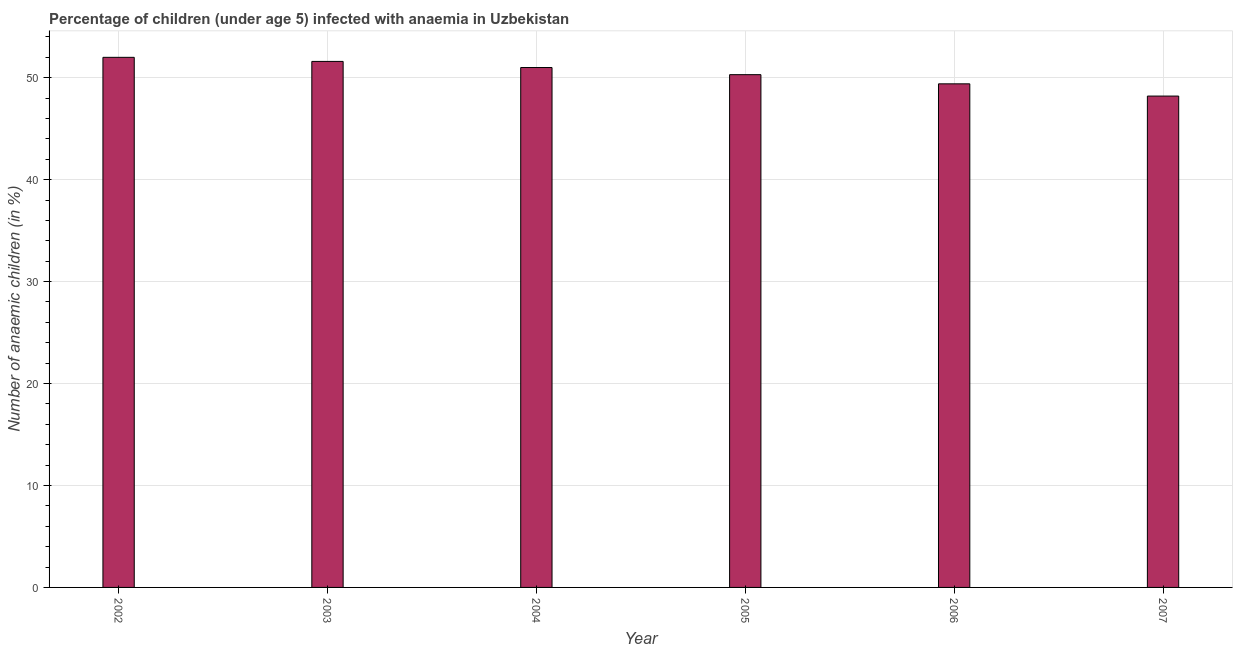Does the graph contain any zero values?
Offer a very short reply. No. Does the graph contain grids?
Give a very brief answer. Yes. What is the title of the graph?
Provide a short and direct response. Percentage of children (under age 5) infected with anaemia in Uzbekistan. What is the label or title of the Y-axis?
Give a very brief answer. Number of anaemic children (in %). Across all years, what is the maximum number of anaemic children?
Your response must be concise. 52. Across all years, what is the minimum number of anaemic children?
Provide a short and direct response. 48.2. In which year was the number of anaemic children maximum?
Provide a succinct answer. 2002. What is the sum of the number of anaemic children?
Provide a short and direct response. 302.5. What is the difference between the number of anaemic children in 2002 and 2005?
Your answer should be very brief. 1.7. What is the average number of anaemic children per year?
Your answer should be compact. 50.42. What is the median number of anaemic children?
Make the answer very short. 50.65. What is the ratio of the number of anaemic children in 2003 to that in 2006?
Your answer should be very brief. 1.04. Is the difference between the number of anaemic children in 2002 and 2006 greater than the difference between any two years?
Ensure brevity in your answer.  No. What is the difference between the highest and the second highest number of anaemic children?
Keep it short and to the point. 0.4. Is the sum of the number of anaemic children in 2003 and 2005 greater than the maximum number of anaemic children across all years?
Provide a short and direct response. Yes. What is the difference between the highest and the lowest number of anaemic children?
Provide a succinct answer. 3.8. Are all the bars in the graph horizontal?
Give a very brief answer. No. What is the Number of anaemic children (in %) in 2002?
Make the answer very short. 52. What is the Number of anaemic children (in %) of 2003?
Offer a terse response. 51.6. What is the Number of anaemic children (in %) of 2004?
Your response must be concise. 51. What is the Number of anaemic children (in %) in 2005?
Your answer should be very brief. 50.3. What is the Number of anaemic children (in %) in 2006?
Ensure brevity in your answer.  49.4. What is the Number of anaemic children (in %) of 2007?
Ensure brevity in your answer.  48.2. What is the difference between the Number of anaemic children (in %) in 2002 and 2003?
Your answer should be compact. 0.4. What is the difference between the Number of anaemic children (in %) in 2003 and 2004?
Provide a succinct answer. 0.6. What is the difference between the Number of anaemic children (in %) in 2003 and 2005?
Your answer should be very brief. 1.3. What is the difference between the Number of anaemic children (in %) in 2004 and 2005?
Your answer should be very brief. 0.7. What is the difference between the Number of anaemic children (in %) in 2004 and 2007?
Provide a short and direct response. 2.8. What is the difference between the Number of anaemic children (in %) in 2005 and 2006?
Offer a very short reply. 0.9. What is the difference between the Number of anaemic children (in %) in 2005 and 2007?
Keep it short and to the point. 2.1. What is the difference between the Number of anaemic children (in %) in 2006 and 2007?
Provide a succinct answer. 1.2. What is the ratio of the Number of anaemic children (in %) in 2002 to that in 2005?
Give a very brief answer. 1.03. What is the ratio of the Number of anaemic children (in %) in 2002 to that in 2006?
Your answer should be compact. 1.05. What is the ratio of the Number of anaemic children (in %) in 2002 to that in 2007?
Your answer should be compact. 1.08. What is the ratio of the Number of anaemic children (in %) in 2003 to that in 2004?
Provide a succinct answer. 1.01. What is the ratio of the Number of anaemic children (in %) in 2003 to that in 2006?
Ensure brevity in your answer.  1.04. What is the ratio of the Number of anaemic children (in %) in 2003 to that in 2007?
Ensure brevity in your answer.  1.07. What is the ratio of the Number of anaemic children (in %) in 2004 to that in 2005?
Keep it short and to the point. 1.01. What is the ratio of the Number of anaemic children (in %) in 2004 to that in 2006?
Your answer should be very brief. 1.03. What is the ratio of the Number of anaemic children (in %) in 2004 to that in 2007?
Your response must be concise. 1.06. What is the ratio of the Number of anaemic children (in %) in 2005 to that in 2006?
Your answer should be very brief. 1.02. What is the ratio of the Number of anaemic children (in %) in 2005 to that in 2007?
Your response must be concise. 1.04. 